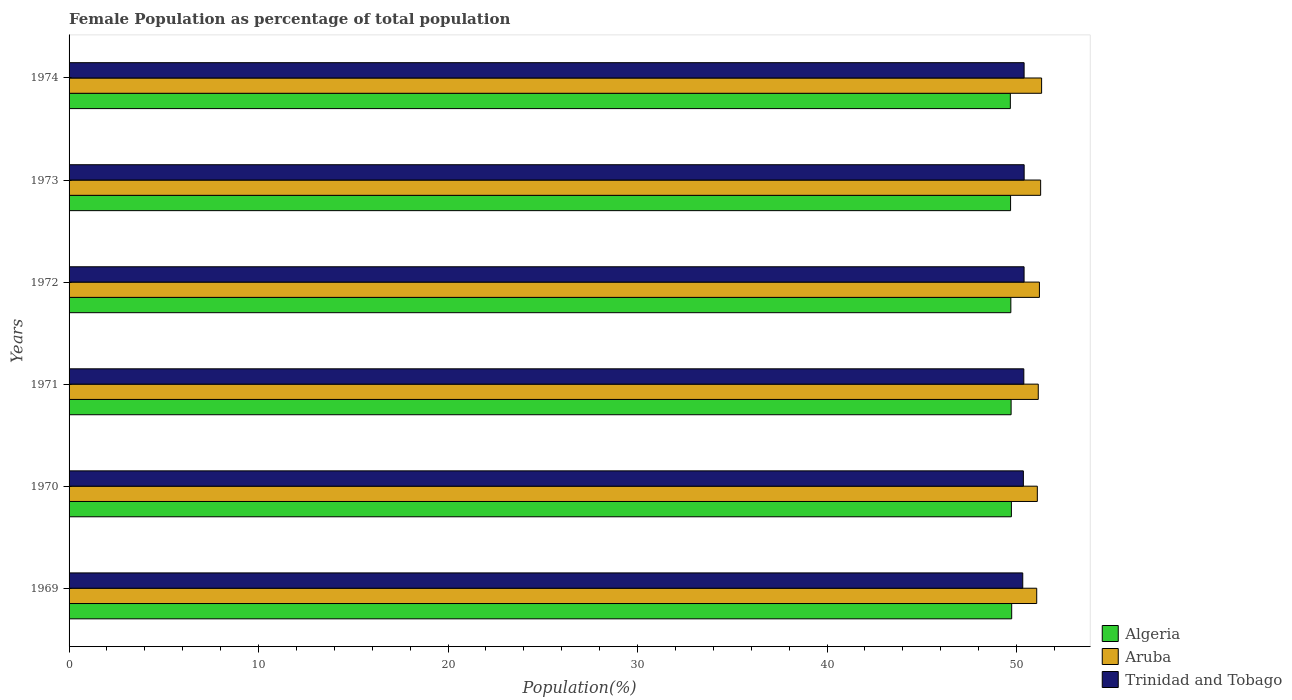How many different coloured bars are there?
Your answer should be very brief. 3. Are the number of bars per tick equal to the number of legend labels?
Make the answer very short. Yes. How many bars are there on the 4th tick from the top?
Provide a succinct answer. 3. How many bars are there on the 4th tick from the bottom?
Your answer should be compact. 3. What is the female population in in Trinidad and Tobago in 1969?
Give a very brief answer. 50.33. Across all years, what is the maximum female population in in Aruba?
Your answer should be very brief. 51.32. Across all years, what is the minimum female population in in Algeria?
Your response must be concise. 49.67. In which year was the female population in in Aruba minimum?
Your answer should be very brief. 1969. What is the total female population in in Aruba in the graph?
Your answer should be very brief. 307.11. What is the difference between the female population in in Trinidad and Tobago in 1969 and that in 1972?
Your response must be concise. -0.07. What is the difference between the female population in in Aruba in 1970 and the female population in in Trinidad and Tobago in 1974?
Ensure brevity in your answer.  0.7. What is the average female population in in Algeria per year?
Your answer should be compact. 49.71. In the year 1973, what is the difference between the female population in in Trinidad and Tobago and female population in in Algeria?
Provide a short and direct response. 0.72. In how many years, is the female population in in Trinidad and Tobago greater than 36 %?
Make the answer very short. 6. What is the ratio of the female population in in Trinidad and Tobago in 1970 to that in 1971?
Offer a terse response. 1. Is the female population in in Trinidad and Tobago in 1969 less than that in 1971?
Make the answer very short. Yes. Is the difference between the female population in in Trinidad and Tobago in 1970 and 1971 greater than the difference between the female population in in Algeria in 1970 and 1971?
Provide a short and direct response. No. What is the difference between the highest and the second highest female population in in Trinidad and Tobago?
Offer a terse response. 0. What is the difference between the highest and the lowest female population in in Algeria?
Your response must be concise. 0.07. In how many years, is the female population in in Trinidad and Tobago greater than the average female population in in Trinidad and Tobago taken over all years?
Give a very brief answer. 4. What does the 1st bar from the top in 1972 represents?
Provide a succinct answer. Trinidad and Tobago. What does the 1st bar from the bottom in 1971 represents?
Make the answer very short. Algeria. How many bars are there?
Your answer should be very brief. 18. How many years are there in the graph?
Make the answer very short. 6. Are the values on the major ticks of X-axis written in scientific E-notation?
Provide a succinct answer. No. How are the legend labels stacked?
Ensure brevity in your answer.  Vertical. What is the title of the graph?
Give a very brief answer. Female Population as percentage of total population. What is the label or title of the X-axis?
Provide a succinct answer. Population(%). What is the Population(%) in Algeria in 1969?
Make the answer very short. 49.74. What is the Population(%) of Aruba in 1969?
Provide a succinct answer. 51.06. What is the Population(%) of Trinidad and Tobago in 1969?
Your answer should be compact. 50.33. What is the Population(%) in Algeria in 1970?
Offer a terse response. 49.73. What is the Population(%) of Aruba in 1970?
Provide a short and direct response. 51.1. What is the Population(%) of Trinidad and Tobago in 1970?
Make the answer very short. 50.36. What is the Population(%) of Algeria in 1971?
Your answer should be compact. 49.71. What is the Population(%) of Aruba in 1971?
Your answer should be compact. 51.15. What is the Population(%) in Trinidad and Tobago in 1971?
Keep it short and to the point. 50.38. What is the Population(%) of Algeria in 1972?
Ensure brevity in your answer.  49.7. What is the Population(%) of Aruba in 1972?
Your response must be concise. 51.21. What is the Population(%) of Trinidad and Tobago in 1972?
Ensure brevity in your answer.  50.4. What is the Population(%) in Algeria in 1973?
Give a very brief answer. 49.68. What is the Population(%) in Aruba in 1973?
Your answer should be compact. 51.27. What is the Population(%) of Trinidad and Tobago in 1973?
Offer a very short reply. 50.4. What is the Population(%) of Algeria in 1974?
Offer a very short reply. 49.67. What is the Population(%) in Aruba in 1974?
Your answer should be very brief. 51.32. What is the Population(%) in Trinidad and Tobago in 1974?
Your answer should be compact. 50.4. Across all years, what is the maximum Population(%) of Algeria?
Offer a terse response. 49.74. Across all years, what is the maximum Population(%) of Aruba?
Keep it short and to the point. 51.32. Across all years, what is the maximum Population(%) in Trinidad and Tobago?
Give a very brief answer. 50.4. Across all years, what is the minimum Population(%) in Algeria?
Provide a succinct answer. 49.67. Across all years, what is the minimum Population(%) in Aruba?
Your response must be concise. 51.06. Across all years, what is the minimum Population(%) of Trinidad and Tobago?
Provide a succinct answer. 50.33. What is the total Population(%) of Algeria in the graph?
Provide a short and direct response. 298.24. What is the total Population(%) of Aruba in the graph?
Offer a very short reply. 307.11. What is the total Population(%) of Trinidad and Tobago in the graph?
Make the answer very short. 302.27. What is the difference between the Population(%) in Algeria in 1969 and that in 1970?
Provide a succinct answer. 0.02. What is the difference between the Population(%) in Aruba in 1969 and that in 1970?
Offer a terse response. -0.03. What is the difference between the Population(%) in Trinidad and Tobago in 1969 and that in 1970?
Offer a very short reply. -0.03. What is the difference between the Population(%) in Algeria in 1969 and that in 1971?
Your answer should be very brief. 0.03. What is the difference between the Population(%) in Aruba in 1969 and that in 1971?
Your response must be concise. -0.08. What is the difference between the Population(%) in Trinidad and Tobago in 1969 and that in 1971?
Offer a very short reply. -0.06. What is the difference between the Population(%) of Algeria in 1969 and that in 1972?
Make the answer very short. 0.04. What is the difference between the Population(%) in Aruba in 1969 and that in 1972?
Your answer should be compact. -0.14. What is the difference between the Population(%) of Trinidad and Tobago in 1969 and that in 1972?
Offer a very short reply. -0.07. What is the difference between the Population(%) of Algeria in 1969 and that in 1973?
Provide a succinct answer. 0.06. What is the difference between the Population(%) of Aruba in 1969 and that in 1973?
Your answer should be very brief. -0.21. What is the difference between the Population(%) in Trinidad and Tobago in 1969 and that in 1973?
Your answer should be compact. -0.07. What is the difference between the Population(%) of Algeria in 1969 and that in 1974?
Offer a very short reply. 0.07. What is the difference between the Population(%) in Aruba in 1969 and that in 1974?
Make the answer very short. -0.26. What is the difference between the Population(%) in Trinidad and Tobago in 1969 and that in 1974?
Your response must be concise. -0.07. What is the difference between the Population(%) in Algeria in 1970 and that in 1971?
Offer a terse response. 0.01. What is the difference between the Population(%) in Aruba in 1970 and that in 1971?
Keep it short and to the point. -0.05. What is the difference between the Population(%) in Trinidad and Tobago in 1970 and that in 1971?
Ensure brevity in your answer.  -0.02. What is the difference between the Population(%) in Algeria in 1970 and that in 1972?
Give a very brief answer. 0.03. What is the difference between the Population(%) of Aruba in 1970 and that in 1972?
Offer a very short reply. -0.11. What is the difference between the Population(%) of Trinidad and Tobago in 1970 and that in 1972?
Ensure brevity in your answer.  -0.04. What is the difference between the Population(%) in Algeria in 1970 and that in 1973?
Your answer should be very brief. 0.04. What is the difference between the Population(%) in Aruba in 1970 and that in 1973?
Offer a terse response. -0.17. What is the difference between the Population(%) in Trinidad and Tobago in 1970 and that in 1973?
Your answer should be compact. -0.04. What is the difference between the Population(%) in Algeria in 1970 and that in 1974?
Your response must be concise. 0.06. What is the difference between the Population(%) in Aruba in 1970 and that in 1974?
Offer a very short reply. -0.23. What is the difference between the Population(%) in Trinidad and Tobago in 1970 and that in 1974?
Make the answer very short. -0.04. What is the difference between the Population(%) in Algeria in 1971 and that in 1972?
Keep it short and to the point. 0.01. What is the difference between the Population(%) of Aruba in 1971 and that in 1972?
Give a very brief answer. -0.06. What is the difference between the Population(%) of Trinidad and Tobago in 1971 and that in 1972?
Ensure brevity in your answer.  -0.01. What is the difference between the Population(%) of Algeria in 1971 and that in 1973?
Offer a terse response. 0.03. What is the difference between the Population(%) in Aruba in 1971 and that in 1973?
Offer a terse response. -0.12. What is the difference between the Population(%) of Trinidad and Tobago in 1971 and that in 1973?
Provide a succinct answer. -0.02. What is the difference between the Population(%) in Algeria in 1971 and that in 1974?
Make the answer very short. 0.04. What is the difference between the Population(%) of Aruba in 1971 and that in 1974?
Keep it short and to the point. -0.18. What is the difference between the Population(%) in Trinidad and Tobago in 1971 and that in 1974?
Offer a very short reply. -0.02. What is the difference between the Population(%) in Algeria in 1972 and that in 1973?
Your answer should be compact. 0.01. What is the difference between the Population(%) of Aruba in 1972 and that in 1973?
Your answer should be compact. -0.06. What is the difference between the Population(%) of Trinidad and Tobago in 1972 and that in 1973?
Offer a very short reply. -0. What is the difference between the Population(%) in Algeria in 1972 and that in 1974?
Your answer should be compact. 0.03. What is the difference between the Population(%) in Aruba in 1972 and that in 1974?
Offer a terse response. -0.12. What is the difference between the Population(%) in Trinidad and Tobago in 1972 and that in 1974?
Your answer should be compact. -0. What is the difference between the Population(%) in Algeria in 1973 and that in 1974?
Offer a terse response. 0.01. What is the difference between the Population(%) of Aruba in 1973 and that in 1974?
Ensure brevity in your answer.  -0.05. What is the difference between the Population(%) in Trinidad and Tobago in 1973 and that in 1974?
Keep it short and to the point. 0. What is the difference between the Population(%) of Algeria in 1969 and the Population(%) of Aruba in 1970?
Provide a short and direct response. -1.35. What is the difference between the Population(%) in Algeria in 1969 and the Population(%) in Trinidad and Tobago in 1970?
Give a very brief answer. -0.62. What is the difference between the Population(%) of Aruba in 1969 and the Population(%) of Trinidad and Tobago in 1970?
Make the answer very short. 0.7. What is the difference between the Population(%) in Algeria in 1969 and the Population(%) in Aruba in 1971?
Make the answer very short. -1.4. What is the difference between the Population(%) of Algeria in 1969 and the Population(%) of Trinidad and Tobago in 1971?
Provide a short and direct response. -0.64. What is the difference between the Population(%) in Aruba in 1969 and the Population(%) in Trinidad and Tobago in 1971?
Your answer should be very brief. 0.68. What is the difference between the Population(%) in Algeria in 1969 and the Population(%) in Aruba in 1972?
Offer a very short reply. -1.46. What is the difference between the Population(%) in Algeria in 1969 and the Population(%) in Trinidad and Tobago in 1972?
Ensure brevity in your answer.  -0.65. What is the difference between the Population(%) in Aruba in 1969 and the Population(%) in Trinidad and Tobago in 1972?
Offer a very short reply. 0.67. What is the difference between the Population(%) of Algeria in 1969 and the Population(%) of Aruba in 1973?
Your answer should be very brief. -1.53. What is the difference between the Population(%) of Algeria in 1969 and the Population(%) of Trinidad and Tobago in 1973?
Provide a short and direct response. -0.66. What is the difference between the Population(%) in Aruba in 1969 and the Population(%) in Trinidad and Tobago in 1973?
Offer a terse response. 0.66. What is the difference between the Population(%) in Algeria in 1969 and the Population(%) in Aruba in 1974?
Keep it short and to the point. -1.58. What is the difference between the Population(%) in Algeria in 1969 and the Population(%) in Trinidad and Tobago in 1974?
Your response must be concise. -0.66. What is the difference between the Population(%) of Aruba in 1969 and the Population(%) of Trinidad and Tobago in 1974?
Your answer should be very brief. 0.67. What is the difference between the Population(%) in Algeria in 1970 and the Population(%) in Aruba in 1971?
Your answer should be very brief. -1.42. What is the difference between the Population(%) in Algeria in 1970 and the Population(%) in Trinidad and Tobago in 1971?
Your response must be concise. -0.66. What is the difference between the Population(%) in Aruba in 1970 and the Population(%) in Trinidad and Tobago in 1971?
Give a very brief answer. 0.71. What is the difference between the Population(%) in Algeria in 1970 and the Population(%) in Aruba in 1972?
Your response must be concise. -1.48. What is the difference between the Population(%) of Algeria in 1970 and the Population(%) of Trinidad and Tobago in 1972?
Your response must be concise. -0.67. What is the difference between the Population(%) in Aruba in 1970 and the Population(%) in Trinidad and Tobago in 1972?
Provide a succinct answer. 0.7. What is the difference between the Population(%) in Algeria in 1970 and the Population(%) in Aruba in 1973?
Make the answer very short. -1.54. What is the difference between the Population(%) of Algeria in 1970 and the Population(%) of Trinidad and Tobago in 1973?
Ensure brevity in your answer.  -0.67. What is the difference between the Population(%) of Aruba in 1970 and the Population(%) of Trinidad and Tobago in 1973?
Offer a very short reply. 0.69. What is the difference between the Population(%) of Algeria in 1970 and the Population(%) of Aruba in 1974?
Make the answer very short. -1.59. What is the difference between the Population(%) in Algeria in 1970 and the Population(%) in Trinidad and Tobago in 1974?
Your response must be concise. -0.67. What is the difference between the Population(%) in Aruba in 1970 and the Population(%) in Trinidad and Tobago in 1974?
Your response must be concise. 0.7. What is the difference between the Population(%) in Algeria in 1971 and the Population(%) in Aruba in 1972?
Provide a short and direct response. -1.49. What is the difference between the Population(%) of Algeria in 1971 and the Population(%) of Trinidad and Tobago in 1972?
Ensure brevity in your answer.  -0.68. What is the difference between the Population(%) of Aruba in 1971 and the Population(%) of Trinidad and Tobago in 1972?
Offer a very short reply. 0.75. What is the difference between the Population(%) of Algeria in 1971 and the Population(%) of Aruba in 1973?
Ensure brevity in your answer.  -1.56. What is the difference between the Population(%) of Algeria in 1971 and the Population(%) of Trinidad and Tobago in 1973?
Provide a succinct answer. -0.69. What is the difference between the Population(%) in Aruba in 1971 and the Population(%) in Trinidad and Tobago in 1973?
Ensure brevity in your answer.  0.74. What is the difference between the Population(%) of Algeria in 1971 and the Population(%) of Aruba in 1974?
Provide a succinct answer. -1.61. What is the difference between the Population(%) in Algeria in 1971 and the Population(%) in Trinidad and Tobago in 1974?
Provide a short and direct response. -0.69. What is the difference between the Population(%) in Aruba in 1971 and the Population(%) in Trinidad and Tobago in 1974?
Your response must be concise. 0.75. What is the difference between the Population(%) in Algeria in 1972 and the Population(%) in Aruba in 1973?
Ensure brevity in your answer.  -1.57. What is the difference between the Population(%) of Algeria in 1972 and the Population(%) of Trinidad and Tobago in 1973?
Your response must be concise. -0.7. What is the difference between the Population(%) in Aruba in 1972 and the Population(%) in Trinidad and Tobago in 1973?
Keep it short and to the point. 0.81. What is the difference between the Population(%) in Algeria in 1972 and the Population(%) in Aruba in 1974?
Keep it short and to the point. -1.62. What is the difference between the Population(%) in Algeria in 1972 and the Population(%) in Trinidad and Tobago in 1974?
Your answer should be compact. -0.7. What is the difference between the Population(%) of Aruba in 1972 and the Population(%) of Trinidad and Tobago in 1974?
Your response must be concise. 0.81. What is the difference between the Population(%) of Algeria in 1973 and the Population(%) of Aruba in 1974?
Ensure brevity in your answer.  -1.64. What is the difference between the Population(%) in Algeria in 1973 and the Population(%) in Trinidad and Tobago in 1974?
Offer a very short reply. -0.71. What is the difference between the Population(%) in Aruba in 1973 and the Population(%) in Trinidad and Tobago in 1974?
Make the answer very short. 0.87. What is the average Population(%) of Algeria per year?
Your answer should be very brief. 49.71. What is the average Population(%) in Aruba per year?
Keep it short and to the point. 51.18. What is the average Population(%) in Trinidad and Tobago per year?
Offer a very short reply. 50.38. In the year 1969, what is the difference between the Population(%) of Algeria and Population(%) of Aruba?
Offer a terse response. -1.32. In the year 1969, what is the difference between the Population(%) of Algeria and Population(%) of Trinidad and Tobago?
Offer a terse response. -0.58. In the year 1969, what is the difference between the Population(%) in Aruba and Population(%) in Trinidad and Tobago?
Offer a terse response. 0.74. In the year 1970, what is the difference between the Population(%) in Algeria and Population(%) in Aruba?
Offer a terse response. -1.37. In the year 1970, what is the difference between the Population(%) in Algeria and Population(%) in Trinidad and Tobago?
Give a very brief answer. -0.63. In the year 1970, what is the difference between the Population(%) of Aruba and Population(%) of Trinidad and Tobago?
Give a very brief answer. 0.74. In the year 1971, what is the difference between the Population(%) in Algeria and Population(%) in Aruba?
Make the answer very short. -1.43. In the year 1971, what is the difference between the Population(%) in Algeria and Population(%) in Trinidad and Tobago?
Provide a succinct answer. -0.67. In the year 1971, what is the difference between the Population(%) of Aruba and Population(%) of Trinidad and Tobago?
Your response must be concise. 0.76. In the year 1972, what is the difference between the Population(%) of Algeria and Population(%) of Aruba?
Make the answer very short. -1.51. In the year 1972, what is the difference between the Population(%) of Algeria and Population(%) of Trinidad and Tobago?
Keep it short and to the point. -0.7. In the year 1972, what is the difference between the Population(%) of Aruba and Population(%) of Trinidad and Tobago?
Give a very brief answer. 0.81. In the year 1973, what is the difference between the Population(%) of Algeria and Population(%) of Aruba?
Your answer should be compact. -1.59. In the year 1973, what is the difference between the Population(%) in Algeria and Population(%) in Trinidad and Tobago?
Offer a terse response. -0.72. In the year 1973, what is the difference between the Population(%) in Aruba and Population(%) in Trinidad and Tobago?
Your answer should be very brief. 0.87. In the year 1974, what is the difference between the Population(%) in Algeria and Population(%) in Aruba?
Give a very brief answer. -1.65. In the year 1974, what is the difference between the Population(%) in Algeria and Population(%) in Trinidad and Tobago?
Offer a terse response. -0.73. In the year 1974, what is the difference between the Population(%) in Aruba and Population(%) in Trinidad and Tobago?
Your answer should be very brief. 0.92. What is the ratio of the Population(%) in Algeria in 1969 to that in 1970?
Your answer should be very brief. 1. What is the ratio of the Population(%) of Aruba in 1969 to that in 1970?
Make the answer very short. 1. What is the ratio of the Population(%) of Trinidad and Tobago in 1969 to that in 1971?
Your answer should be compact. 1. What is the ratio of the Population(%) in Algeria in 1969 to that in 1972?
Your answer should be very brief. 1. What is the ratio of the Population(%) in Trinidad and Tobago in 1969 to that in 1972?
Keep it short and to the point. 1. What is the ratio of the Population(%) in Algeria in 1969 to that in 1973?
Ensure brevity in your answer.  1. What is the ratio of the Population(%) of Trinidad and Tobago in 1969 to that in 1973?
Offer a very short reply. 1. What is the ratio of the Population(%) in Trinidad and Tobago in 1969 to that in 1974?
Keep it short and to the point. 1. What is the ratio of the Population(%) in Algeria in 1970 to that in 1971?
Your answer should be very brief. 1. What is the ratio of the Population(%) in Aruba in 1970 to that in 1971?
Keep it short and to the point. 1. What is the ratio of the Population(%) in Trinidad and Tobago in 1970 to that in 1971?
Keep it short and to the point. 1. What is the ratio of the Population(%) of Aruba in 1970 to that in 1972?
Give a very brief answer. 1. What is the ratio of the Population(%) in Algeria in 1970 to that in 1973?
Your answer should be compact. 1. What is the ratio of the Population(%) of Algeria in 1970 to that in 1974?
Make the answer very short. 1. What is the ratio of the Population(%) in Aruba in 1970 to that in 1974?
Your answer should be compact. 1. What is the ratio of the Population(%) in Trinidad and Tobago in 1970 to that in 1974?
Offer a terse response. 1. What is the ratio of the Population(%) of Algeria in 1971 to that in 1972?
Your answer should be compact. 1. What is the ratio of the Population(%) in Aruba in 1971 to that in 1973?
Your answer should be compact. 1. What is the ratio of the Population(%) of Aruba in 1971 to that in 1974?
Give a very brief answer. 1. What is the ratio of the Population(%) of Aruba in 1972 to that in 1973?
Offer a very short reply. 1. What is the ratio of the Population(%) in Trinidad and Tobago in 1972 to that in 1973?
Offer a terse response. 1. What is the ratio of the Population(%) in Algeria in 1972 to that in 1974?
Provide a short and direct response. 1. What is the ratio of the Population(%) in Aruba in 1972 to that in 1974?
Your response must be concise. 1. What is the ratio of the Population(%) in Trinidad and Tobago in 1972 to that in 1974?
Give a very brief answer. 1. What is the difference between the highest and the second highest Population(%) in Algeria?
Make the answer very short. 0.02. What is the difference between the highest and the second highest Population(%) of Aruba?
Offer a terse response. 0.05. What is the difference between the highest and the second highest Population(%) in Trinidad and Tobago?
Make the answer very short. 0. What is the difference between the highest and the lowest Population(%) in Algeria?
Your answer should be compact. 0.07. What is the difference between the highest and the lowest Population(%) of Aruba?
Make the answer very short. 0.26. What is the difference between the highest and the lowest Population(%) of Trinidad and Tobago?
Your answer should be very brief. 0.07. 